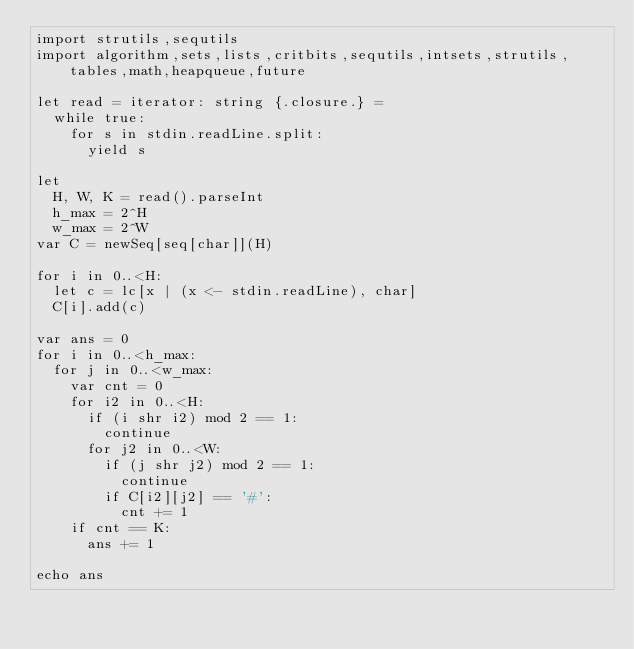Convert code to text. <code><loc_0><loc_0><loc_500><loc_500><_Nim_>import strutils,sequtils
import algorithm,sets,lists,critbits,sequtils,intsets,strutils,tables,math,heapqueue,future

let read = iterator: string {.closure.} =
  while true:
    for s in stdin.readLine.split:
      yield s

let 
  H, W, K = read().parseInt
  h_max = 2^H
  w_max = 2^W
var C = newSeq[seq[char]](H)

for i in 0..<H:
  let c = lc[x | (x <- stdin.readLine), char]
  C[i].add(c)

var ans = 0
for i in 0..<h_max:
  for j in 0..<w_max:
    var cnt = 0
    for i2 in 0..<H:
      if (i shr i2) mod 2 == 1:
        continue
      for j2 in 0..<W:
        if (j shr j2) mod 2 == 1:
          continue
        if C[i2][j2] == '#':
          cnt += 1
    if cnt == K:
      ans += 1

echo ans
</code> 